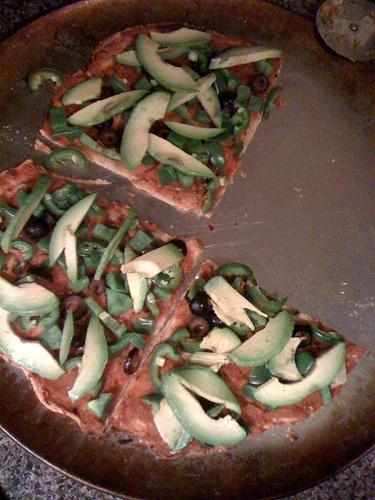What is on the tray? Please explain your reasoning. avocado. The green slices that become white towards the center identify the toppings that aren't peppers or olives on this pizza as avocado. 